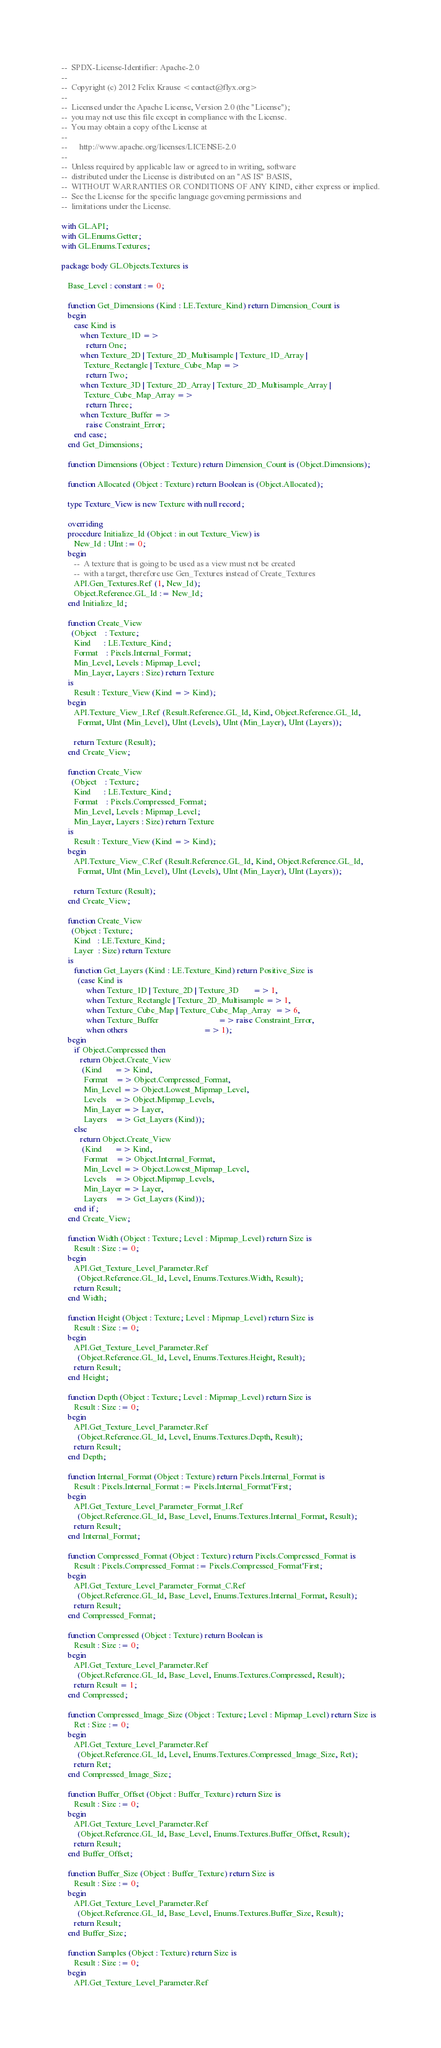Convert code to text. <code><loc_0><loc_0><loc_500><loc_500><_Ada_>--  SPDX-License-Identifier: Apache-2.0
--
--  Copyright (c) 2012 Felix Krause <contact@flyx.org>
--
--  Licensed under the Apache License, Version 2.0 (the "License");
--  you may not use this file except in compliance with the License.
--  You may obtain a copy of the License at
--
--      http://www.apache.org/licenses/LICENSE-2.0
--
--  Unless required by applicable law or agreed to in writing, software
--  distributed under the License is distributed on an "AS IS" BASIS,
--  WITHOUT WARRANTIES OR CONDITIONS OF ANY KIND, either express or implied.
--  See the License for the specific language governing permissions and
--  limitations under the License.

with GL.API;
with GL.Enums.Getter;
with GL.Enums.Textures;

package body GL.Objects.Textures is

   Base_Level : constant := 0;

   function Get_Dimensions (Kind : LE.Texture_Kind) return Dimension_Count is
   begin
      case Kind is
         when Texture_1D =>
            return One;
         when Texture_2D | Texture_2D_Multisample | Texture_1D_Array |
           Texture_Rectangle | Texture_Cube_Map =>
            return Two;
         when Texture_3D | Texture_2D_Array | Texture_2D_Multisample_Array |
           Texture_Cube_Map_Array =>
            return Three;
         when Texture_Buffer =>
            raise Constraint_Error;
      end case;
   end Get_Dimensions;

   function Dimensions (Object : Texture) return Dimension_Count is (Object.Dimensions);

   function Allocated (Object : Texture) return Boolean is (Object.Allocated);

   type Texture_View is new Texture with null record;

   overriding
   procedure Initialize_Id (Object : in out Texture_View) is
      New_Id : UInt := 0;
   begin
      --  A texture that is going to be used as a view must not be created
      --  with a target, therefore use Gen_Textures instead of Create_Textures
      API.Gen_Textures.Ref (1, New_Id);
      Object.Reference.GL_Id := New_Id;
   end Initialize_Id;

   function Create_View
     (Object    : Texture;
      Kind      : LE.Texture_Kind;
      Format    : Pixels.Internal_Format;
      Min_Level, Levels : Mipmap_Level;
      Min_Layer, Layers : Size) return Texture
   is
      Result : Texture_View (Kind => Kind);
   begin
      API.Texture_View_I.Ref (Result.Reference.GL_Id, Kind, Object.Reference.GL_Id,
        Format, UInt (Min_Level), UInt (Levels), UInt (Min_Layer), UInt (Layers));

      return Texture (Result);
   end Create_View;

   function Create_View
     (Object    : Texture;
      Kind      : LE.Texture_Kind;
      Format    : Pixels.Compressed_Format;
      Min_Level, Levels : Mipmap_Level;
      Min_Layer, Layers : Size) return Texture
   is
      Result : Texture_View (Kind => Kind);
   begin
      API.Texture_View_C.Ref (Result.Reference.GL_Id, Kind, Object.Reference.GL_Id,
        Format, UInt (Min_Level), UInt (Levels), UInt (Min_Layer), UInt (Layers));

      return Texture (Result);
   end Create_View;

   function Create_View
     (Object : Texture;
      Kind   : LE.Texture_Kind;
      Layer  : Size) return Texture
   is
      function Get_Layers (Kind : LE.Texture_Kind) return Positive_Size is
        (case Kind is
            when Texture_1D | Texture_2D | Texture_3D       => 1,
            when Texture_Rectangle | Texture_2D_Multisample => 1,
            when Texture_Cube_Map | Texture_Cube_Map_Array  => 6,
            when Texture_Buffer                             => raise Constraint_Error,
            when others                                     => 1);
   begin
      if Object.Compressed then
         return Object.Create_View
          (Kind      => Kind,
           Format    => Object.Compressed_Format,
           Min_Level => Object.Lowest_Mipmap_Level,
           Levels    => Object.Mipmap_Levels,
           Min_Layer => Layer,
           Layers    => Get_Layers (Kind));
      else
         return Object.Create_View
          (Kind      => Kind,
           Format    => Object.Internal_Format,
           Min_Level => Object.Lowest_Mipmap_Level,
           Levels    => Object.Mipmap_Levels,
           Min_Layer => Layer,
           Layers    => Get_Layers (Kind));
      end if;
   end Create_View;

   function Width (Object : Texture; Level : Mipmap_Level) return Size is
      Result : Size := 0;
   begin
      API.Get_Texture_Level_Parameter.Ref
        (Object.Reference.GL_Id, Level, Enums.Textures.Width, Result);
      return Result;
   end Width;

   function Height (Object : Texture; Level : Mipmap_Level) return Size is
      Result : Size := 0;
   begin
      API.Get_Texture_Level_Parameter.Ref
        (Object.Reference.GL_Id, Level, Enums.Textures.Height, Result);
      return Result;
   end Height;

   function Depth (Object : Texture; Level : Mipmap_Level) return Size is
      Result : Size := 0;
   begin
      API.Get_Texture_Level_Parameter.Ref
        (Object.Reference.GL_Id, Level, Enums.Textures.Depth, Result);
      return Result;
   end Depth;

   function Internal_Format (Object : Texture) return Pixels.Internal_Format is
      Result : Pixels.Internal_Format := Pixels.Internal_Format'First;
   begin
      API.Get_Texture_Level_Parameter_Format_I.Ref
        (Object.Reference.GL_Id, Base_Level, Enums.Textures.Internal_Format, Result);
      return Result;
   end Internal_Format;

   function Compressed_Format (Object : Texture) return Pixels.Compressed_Format is
      Result : Pixels.Compressed_Format := Pixels.Compressed_Format'First;
   begin
      API.Get_Texture_Level_Parameter_Format_C.Ref
        (Object.Reference.GL_Id, Base_Level, Enums.Textures.Internal_Format, Result);
      return Result;
   end Compressed_Format;

   function Compressed (Object : Texture) return Boolean is
      Result : Size := 0;
   begin
      API.Get_Texture_Level_Parameter.Ref
        (Object.Reference.GL_Id, Base_Level, Enums.Textures.Compressed, Result);
      return Result = 1;
   end Compressed;

   function Compressed_Image_Size (Object : Texture; Level : Mipmap_Level) return Size is
      Ret : Size := 0;
   begin
      API.Get_Texture_Level_Parameter.Ref
        (Object.Reference.GL_Id, Level, Enums.Textures.Compressed_Image_Size, Ret);
      return Ret;
   end Compressed_Image_Size;

   function Buffer_Offset (Object : Buffer_Texture) return Size is
      Result : Size := 0;
   begin
      API.Get_Texture_Level_Parameter.Ref
        (Object.Reference.GL_Id, Base_Level, Enums.Textures.Buffer_Offset, Result);
      return Result;
   end Buffer_Offset;

   function Buffer_Size (Object : Buffer_Texture) return Size is
      Result : Size := 0;
   begin
      API.Get_Texture_Level_Parameter.Ref
        (Object.Reference.GL_Id, Base_Level, Enums.Textures.Buffer_Size, Result);
      return Result;
   end Buffer_Size;

   function Samples (Object : Texture) return Size is
      Result : Size := 0;
   begin
      API.Get_Texture_Level_Parameter.Ref</code> 